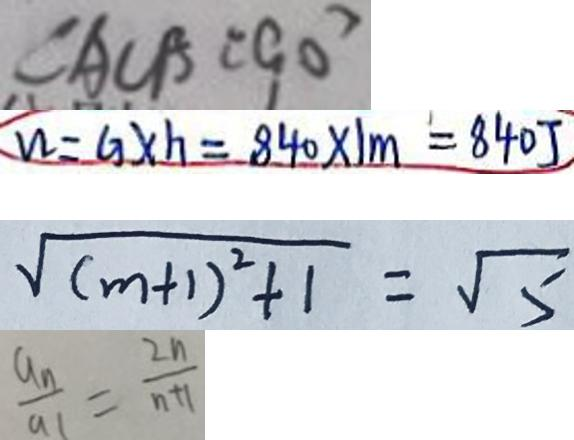<formula> <loc_0><loc_0><loc_500><loc_500>\angle A C B = 9 0 ^ { \circ } 
 W = G \times h = 8 4 0 \times 1 m = 8 4 0 J 
 \sqrt { ( m + 1 ) ^ { 2 } + 1 } = \sqrt { 5 } 
 \frac { a _ { n } } { a _ { 1 } } = \frac { 2 n } { n + 1 }</formula> 